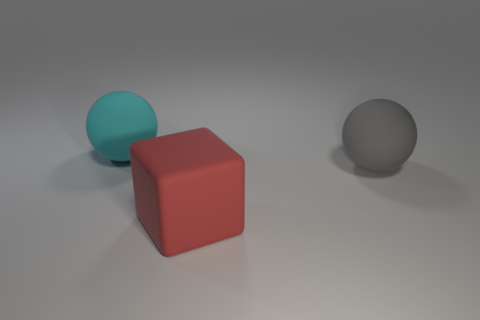What number of big gray things are behind the large rubber object that is right of the object that is in front of the gray thing?
Give a very brief answer. 0. Is the number of large gray objects on the right side of the cyan object the same as the number of tiny gray spheres?
Ensure brevity in your answer.  No. How many balls are big gray matte objects or cyan matte things?
Your answer should be very brief. 2. Are there an equal number of objects to the right of the red block and big cyan things that are on the left side of the large cyan rubber thing?
Keep it short and to the point. No. The large cube is what color?
Give a very brief answer. Red. How many objects are either things that are behind the large gray thing or large red metal spheres?
Keep it short and to the point. 1. There is a gray sphere that is behind the red object; does it have the same size as the object that is on the left side of the red matte cube?
Offer a terse response. Yes. Is there anything else that has the same material as the cyan thing?
Offer a terse response. Yes. What number of things are either big matte objects that are on the left side of the gray matte sphere or big balls right of the red object?
Your answer should be compact. 3. Is the material of the gray object the same as the big sphere that is left of the big red cube?
Your response must be concise. Yes. 